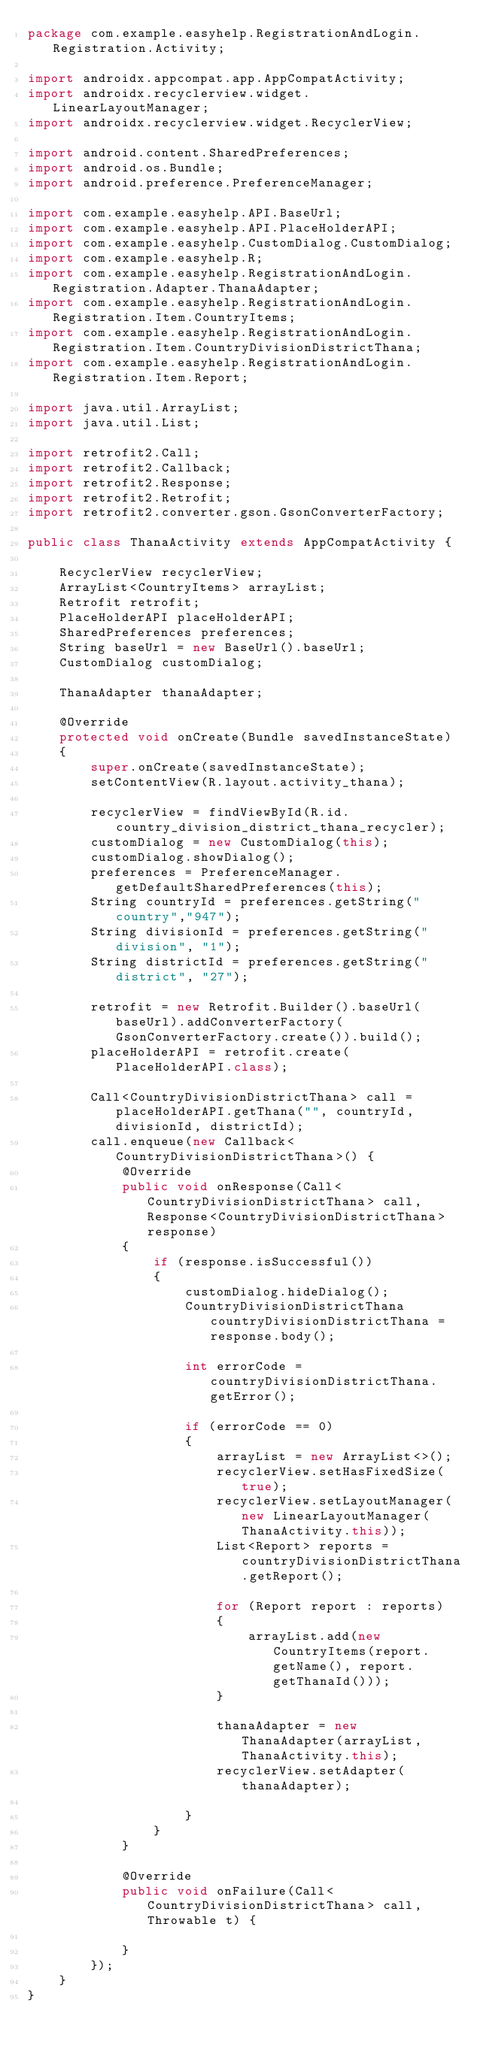Convert code to text. <code><loc_0><loc_0><loc_500><loc_500><_Java_>package com.example.easyhelp.RegistrationAndLogin.Registration.Activity;

import androidx.appcompat.app.AppCompatActivity;
import androidx.recyclerview.widget.LinearLayoutManager;
import androidx.recyclerview.widget.RecyclerView;

import android.content.SharedPreferences;
import android.os.Bundle;
import android.preference.PreferenceManager;

import com.example.easyhelp.API.BaseUrl;
import com.example.easyhelp.API.PlaceHolderAPI;
import com.example.easyhelp.CustomDialog.CustomDialog;
import com.example.easyhelp.R;
import com.example.easyhelp.RegistrationAndLogin.Registration.Adapter.ThanaAdapter;
import com.example.easyhelp.RegistrationAndLogin.Registration.Item.CountryItems;
import com.example.easyhelp.RegistrationAndLogin.Registration.Item.CountryDivisionDistrictThana;
import com.example.easyhelp.RegistrationAndLogin.Registration.Item.Report;

import java.util.ArrayList;
import java.util.List;

import retrofit2.Call;
import retrofit2.Callback;
import retrofit2.Response;
import retrofit2.Retrofit;
import retrofit2.converter.gson.GsonConverterFactory;

public class ThanaActivity extends AppCompatActivity {

    RecyclerView recyclerView;
    ArrayList<CountryItems> arrayList;
    Retrofit retrofit;
    PlaceHolderAPI placeHolderAPI;
    SharedPreferences preferences;
    String baseUrl = new BaseUrl().baseUrl;
    CustomDialog customDialog;

    ThanaAdapter thanaAdapter;

    @Override
    protected void onCreate(Bundle savedInstanceState)
    {
        super.onCreate(savedInstanceState);
        setContentView(R.layout.activity_thana);

        recyclerView = findViewById(R.id.country_division_district_thana_recycler);
        customDialog = new CustomDialog(this);
        customDialog.showDialog();
        preferences = PreferenceManager.getDefaultSharedPreferences(this);
        String countryId = preferences.getString("country","947");
        String divisionId = preferences.getString("division", "1");
        String districtId = preferences.getString("district", "27");

        retrofit = new Retrofit.Builder().baseUrl(baseUrl).addConverterFactory(GsonConverterFactory.create()).build();
        placeHolderAPI = retrofit.create(PlaceHolderAPI.class);

        Call<CountryDivisionDistrictThana> call = placeHolderAPI.getThana("", countryId, divisionId, districtId);
        call.enqueue(new Callback<CountryDivisionDistrictThana>() {
            @Override
            public void onResponse(Call<CountryDivisionDistrictThana> call, Response<CountryDivisionDistrictThana> response)
            {
                if (response.isSuccessful())
                {
                    customDialog.hideDialog();
                    CountryDivisionDistrictThana countryDivisionDistrictThana = response.body();

                    int errorCode = countryDivisionDistrictThana.getError();

                    if (errorCode == 0)
                    {
                        arrayList = new ArrayList<>();
                        recyclerView.setHasFixedSize(true);
                        recyclerView.setLayoutManager(new LinearLayoutManager(ThanaActivity.this));
                        List<Report> reports = countryDivisionDistrictThana.getReport();

                        for (Report report : reports)
                        {
                            arrayList.add(new CountryItems(report.getName(), report.getThanaId()));
                        }

                        thanaAdapter = new ThanaAdapter(arrayList, ThanaActivity.this);
                        recyclerView.setAdapter(thanaAdapter);

                    }
                }
            }

            @Override
            public void onFailure(Call<CountryDivisionDistrictThana> call, Throwable t) {

            }
        });
    }
}
</code> 